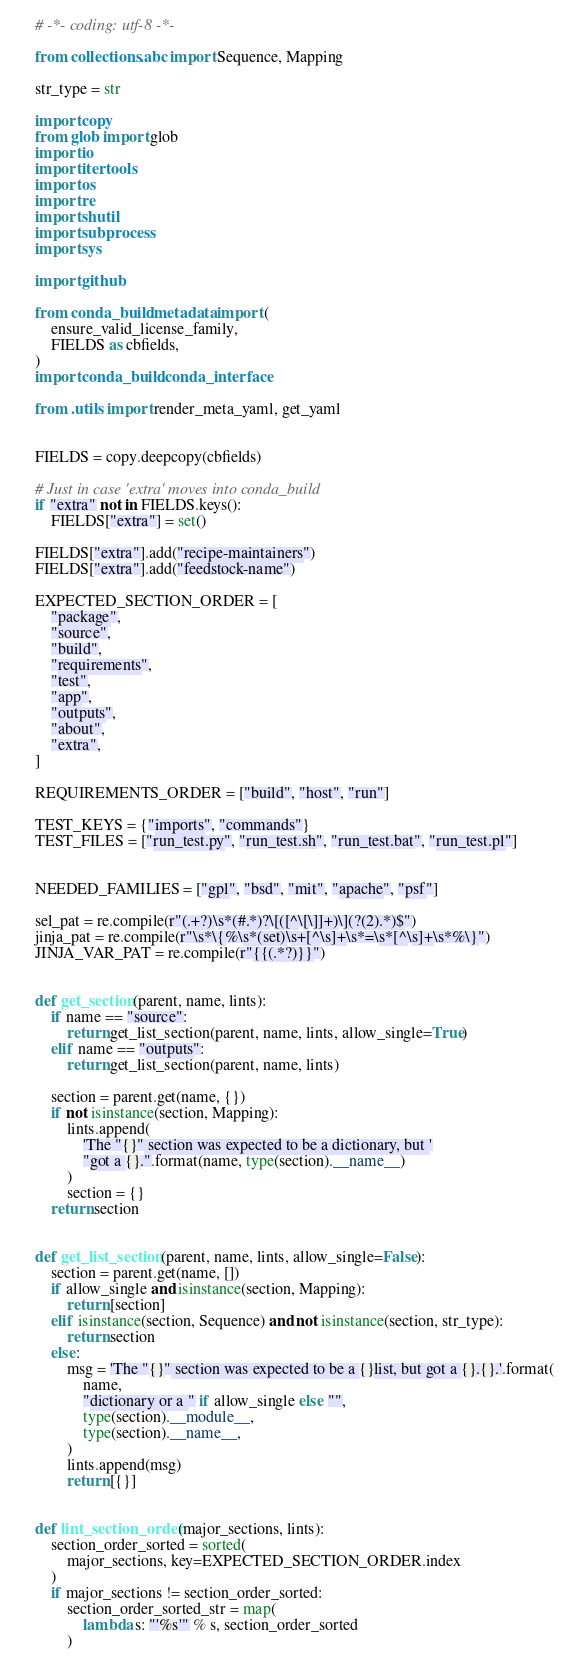Convert code to text. <code><loc_0><loc_0><loc_500><loc_500><_Python_># -*- coding: utf-8 -*-

from collections.abc import Sequence, Mapping

str_type = str

import copy
from glob import glob
import io
import itertools
import os
import re
import shutil
import subprocess
import sys

import github

from conda_build.metadata import (
    ensure_valid_license_family,
    FIELDS as cbfields,
)
import conda_build.conda_interface

from .utils import render_meta_yaml, get_yaml


FIELDS = copy.deepcopy(cbfields)

# Just in case 'extra' moves into conda_build
if "extra" not in FIELDS.keys():
    FIELDS["extra"] = set()

FIELDS["extra"].add("recipe-maintainers")
FIELDS["extra"].add("feedstock-name")

EXPECTED_SECTION_ORDER = [
    "package",
    "source",
    "build",
    "requirements",
    "test",
    "app",
    "outputs",
    "about",
    "extra",
]

REQUIREMENTS_ORDER = ["build", "host", "run"]

TEST_KEYS = {"imports", "commands"}
TEST_FILES = ["run_test.py", "run_test.sh", "run_test.bat", "run_test.pl"]


NEEDED_FAMILIES = ["gpl", "bsd", "mit", "apache", "psf"]

sel_pat = re.compile(r"(.+?)\s*(#.*)?\[([^\[\]]+)\](?(2).*)$")
jinja_pat = re.compile(r"\s*\{%\s*(set)\s+[^\s]+\s*=\s*[^\s]+\s*%\}")
JINJA_VAR_PAT = re.compile(r"{{(.*?)}}")


def get_section(parent, name, lints):
    if name == "source":
        return get_list_section(parent, name, lints, allow_single=True)
    elif name == "outputs":
        return get_list_section(parent, name, lints)

    section = parent.get(name, {})
    if not isinstance(section, Mapping):
        lints.append(
            'The "{}" section was expected to be a dictionary, but '
            "got a {}.".format(name, type(section).__name__)
        )
        section = {}
    return section


def get_list_section(parent, name, lints, allow_single=False):
    section = parent.get(name, [])
    if allow_single and isinstance(section, Mapping):
        return [section]
    elif isinstance(section, Sequence) and not isinstance(section, str_type):
        return section
    else:
        msg = 'The "{}" section was expected to be a {}list, but got a {}.{}.'.format(
            name,
            "dictionary or a " if allow_single else "",
            type(section).__module__,
            type(section).__name__,
        )
        lints.append(msg)
        return [{}]


def lint_section_order(major_sections, lints):
    section_order_sorted = sorted(
        major_sections, key=EXPECTED_SECTION_ORDER.index
    )
    if major_sections != section_order_sorted:
        section_order_sorted_str = map(
            lambda s: "'%s'" % s, section_order_sorted
        )</code> 